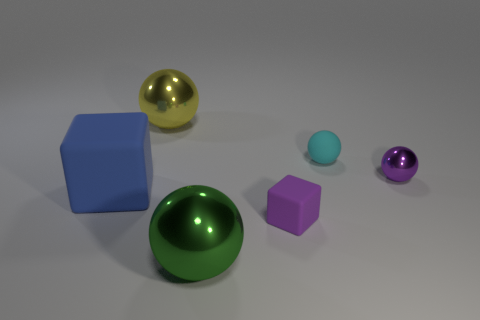Add 2 gray objects. How many objects exist? 8 Subtract all spheres. How many objects are left? 2 Subtract 1 blue blocks. How many objects are left? 5 Subtract all big yellow spheres. Subtract all small rubber cubes. How many objects are left? 4 Add 2 rubber cubes. How many rubber cubes are left? 4 Add 6 rubber balls. How many rubber balls exist? 7 